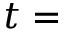<formula> <loc_0><loc_0><loc_500><loc_500>t =</formula> 